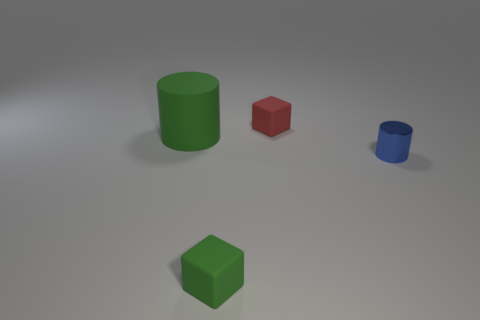What number of things are small yellow matte balls or green objects that are on the left side of the green rubber block?
Give a very brief answer. 1. What color is the cube in front of the green matte thing that is behind the blue cylinder?
Your response must be concise. Green. Is the color of the cylinder on the left side of the tiny red object the same as the metallic cylinder?
Offer a very short reply. No. There is a cube in front of the red thing; what is it made of?
Your answer should be compact. Rubber. How big is the metallic cylinder?
Your answer should be compact. Small. Are the small thing behind the big thing and the big cylinder made of the same material?
Offer a very short reply. Yes. How many large objects are there?
Offer a very short reply. 1. How many objects are matte objects or tiny brown cylinders?
Give a very brief answer. 3. How many red cubes are on the right side of the cylinder right of the rubber cube that is in front of the small red rubber cube?
Ensure brevity in your answer.  0. Is there anything else that has the same color as the tiny shiny object?
Keep it short and to the point. No. 